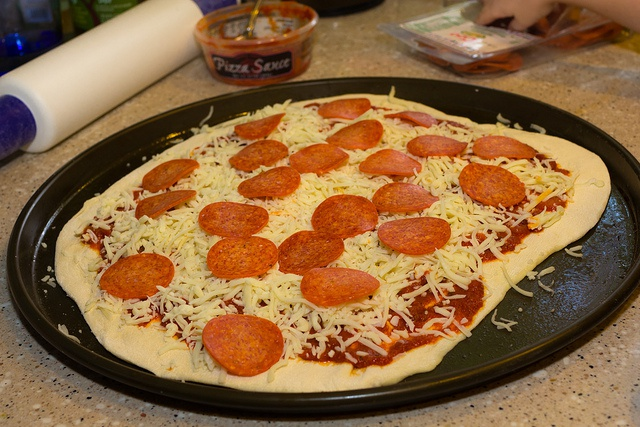Describe the objects in this image and their specific colors. I can see pizza in black, tan, red, and brown tones, bowl in black, maroon, and brown tones, and people in black, brown, and maroon tones in this image. 